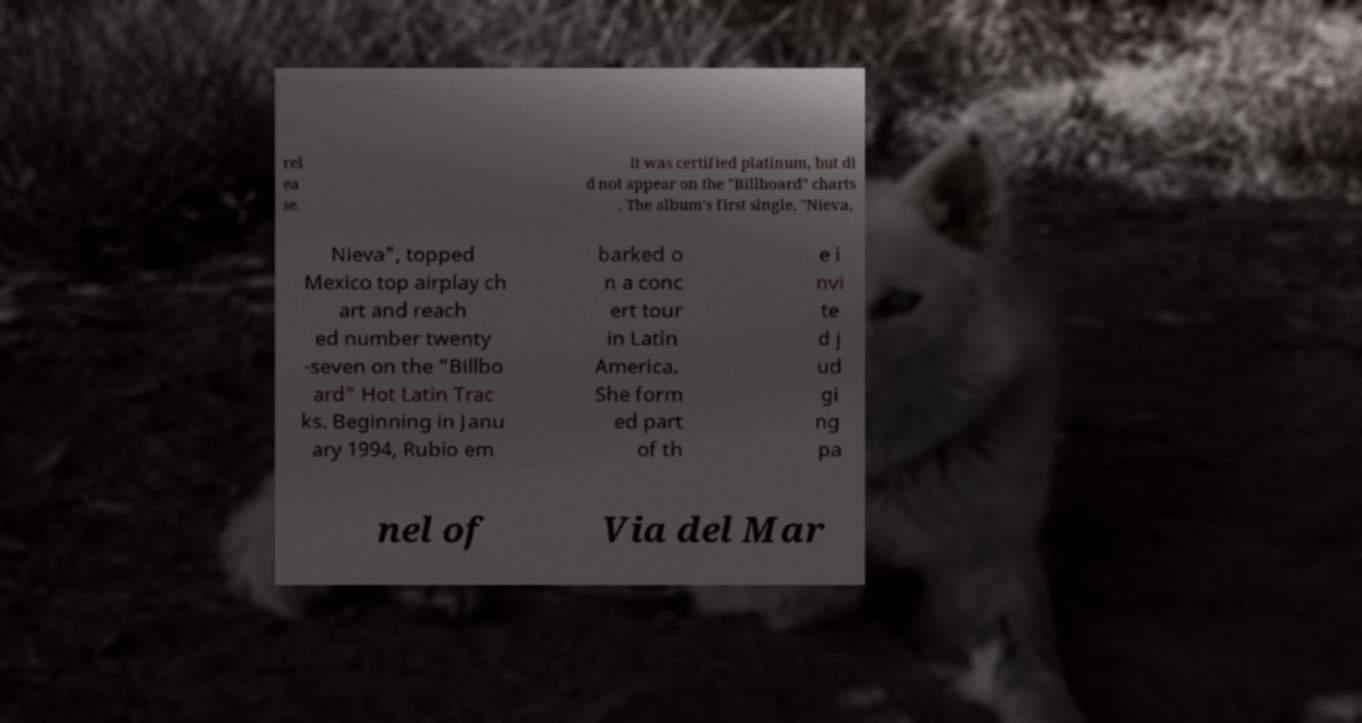Can you read and provide the text displayed in the image?This photo seems to have some interesting text. Can you extract and type it out for me? rel ea se. It was certified platinum, but di d not appear on the "Billboard" charts . The album's first single, "Nieva, Nieva", topped Mexico top airplay ch art and reach ed number twenty -seven on the "Billbo ard" Hot Latin Trac ks. Beginning in Janu ary 1994, Rubio em barked o n a conc ert tour in Latin America. She form ed part of th e i nvi te d j ud gi ng pa nel of Via del Mar 